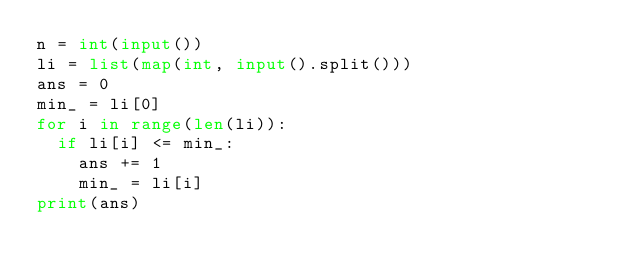Convert code to text. <code><loc_0><loc_0><loc_500><loc_500><_Python_>n = int(input())
li = list(map(int, input().split()))
ans = 0
min_ = li[0]
for i in range(len(li)):
  if li[i] <= min_:
    ans += 1
    min_ = li[i]
print(ans)</code> 